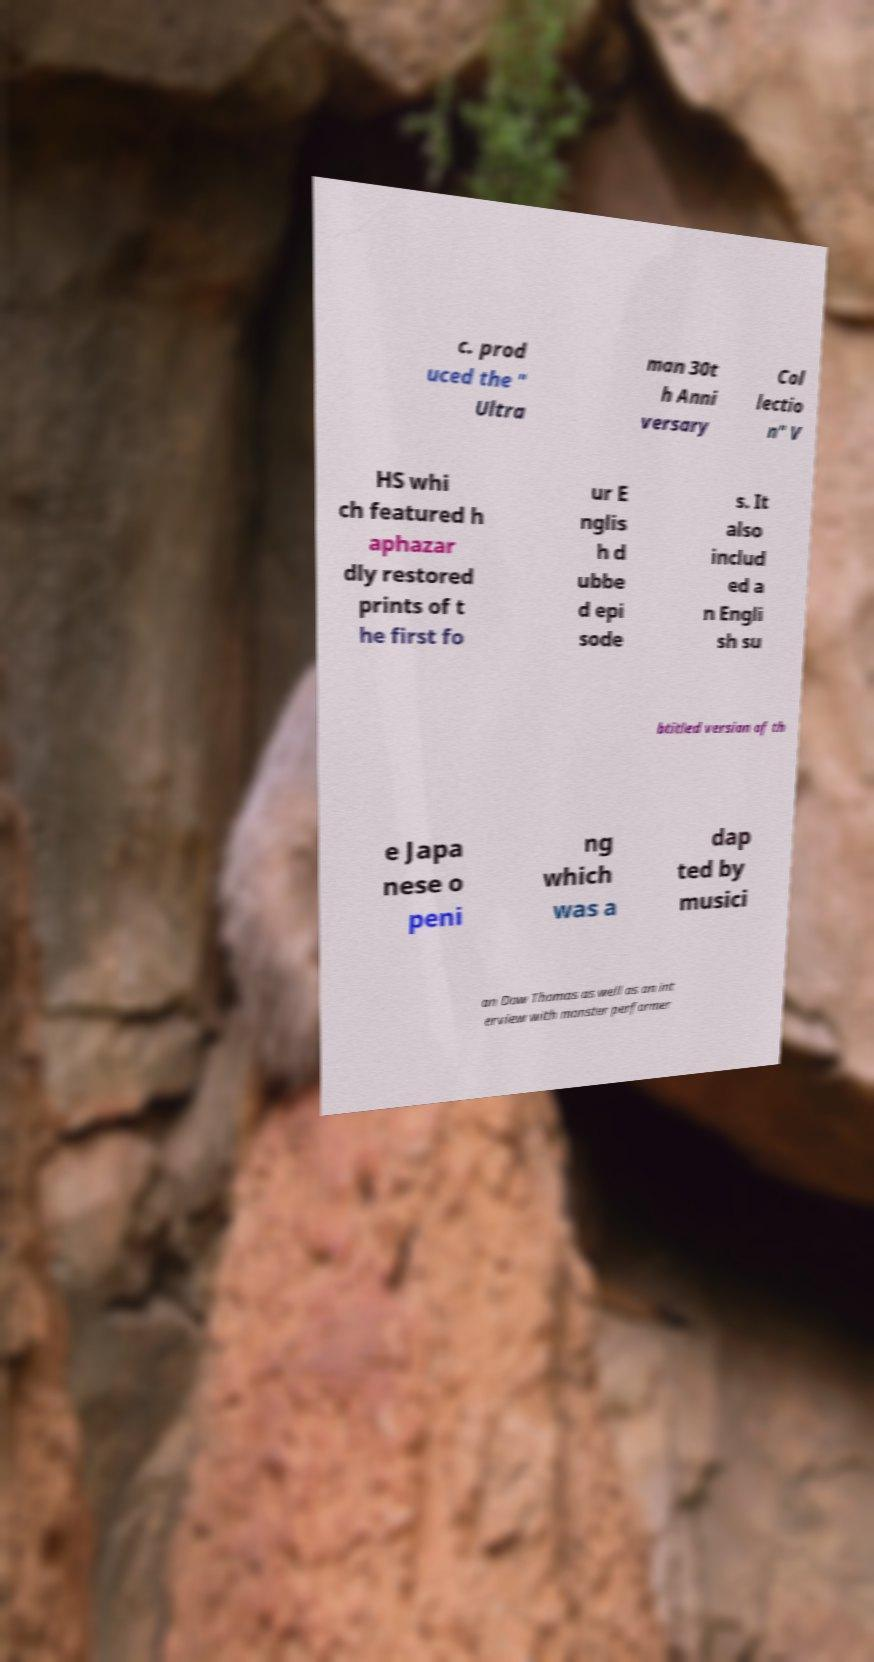Can you accurately transcribe the text from the provided image for me? c. prod uced the " Ultra man 30t h Anni versary Col lectio n" V HS whi ch featured h aphazar dly restored prints of t he first fo ur E nglis h d ubbe d epi sode s. It also includ ed a n Engli sh su btitled version of th e Japa nese o peni ng which was a dap ted by musici an Dow Thomas as well as an int erview with monster performer 